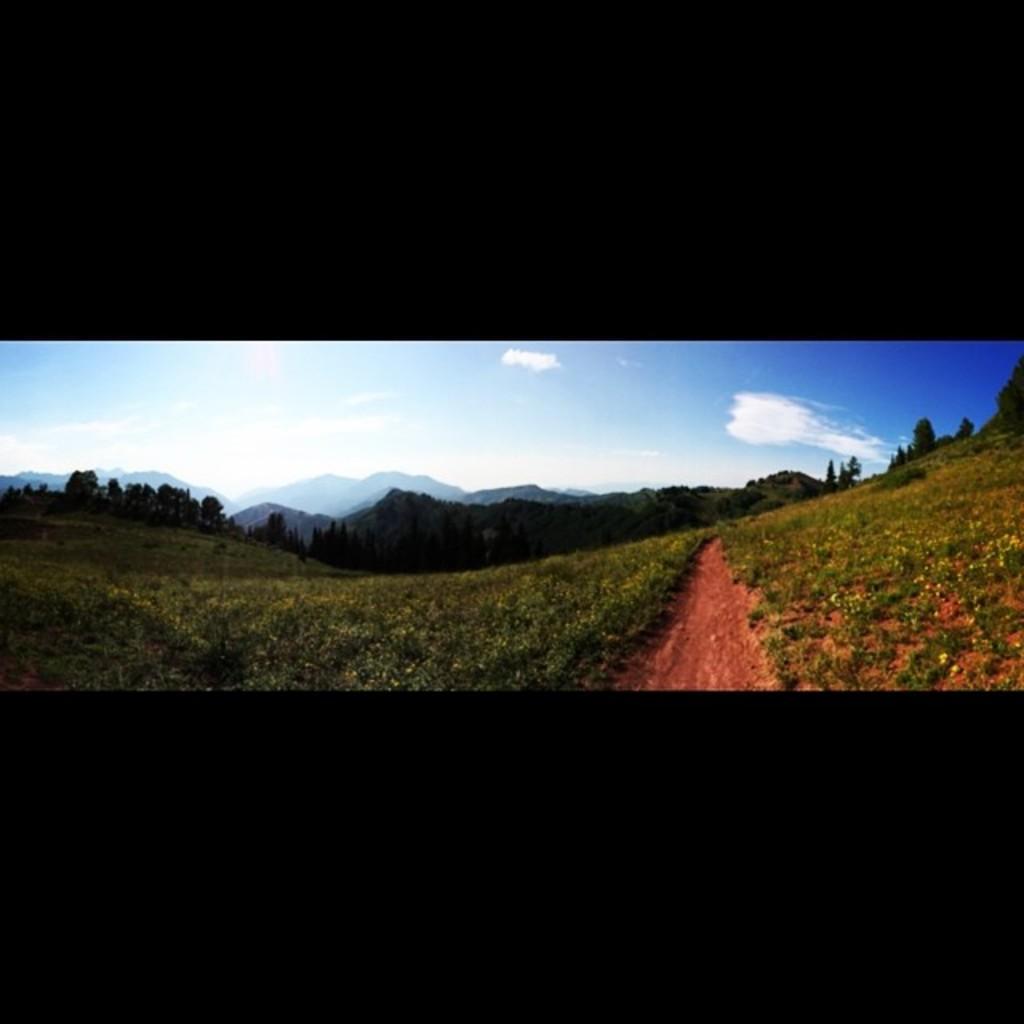Please provide a concise description of this image. In this image we can see a group of plants with flowers and a pathway. On the backside we can see a group of trees, the hills and the sky which looks cloudy. 